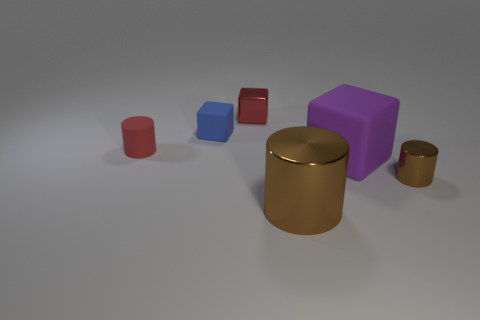What size is the blue thing?
Provide a succinct answer. Small. Is there a tiny red object of the same shape as the large rubber object?
Your answer should be very brief. Yes. Do the tiny red matte object and the big object that is left of the big purple rubber cube have the same shape?
Keep it short and to the point. Yes. How big is the shiny object that is both behind the large cylinder and in front of the big purple rubber object?
Your answer should be compact. Small. What number of small purple metal cylinders are there?
Keep it short and to the point. 0. There is a brown object that is the same size as the red cube; what material is it?
Provide a succinct answer. Metal. Are there any cyan shiny objects that have the same size as the purple block?
Provide a succinct answer. No. There is a small cylinder that is to the right of the blue object; is its color the same as the metallic cylinder to the left of the large purple rubber object?
Your answer should be compact. Yes. What number of matte things are tiny brown things or blue objects?
Offer a very short reply. 1. There is a brown metal cylinder left of the metallic cylinder on the right side of the large purple cube; how many tiny matte cylinders are right of it?
Your response must be concise. 0. 